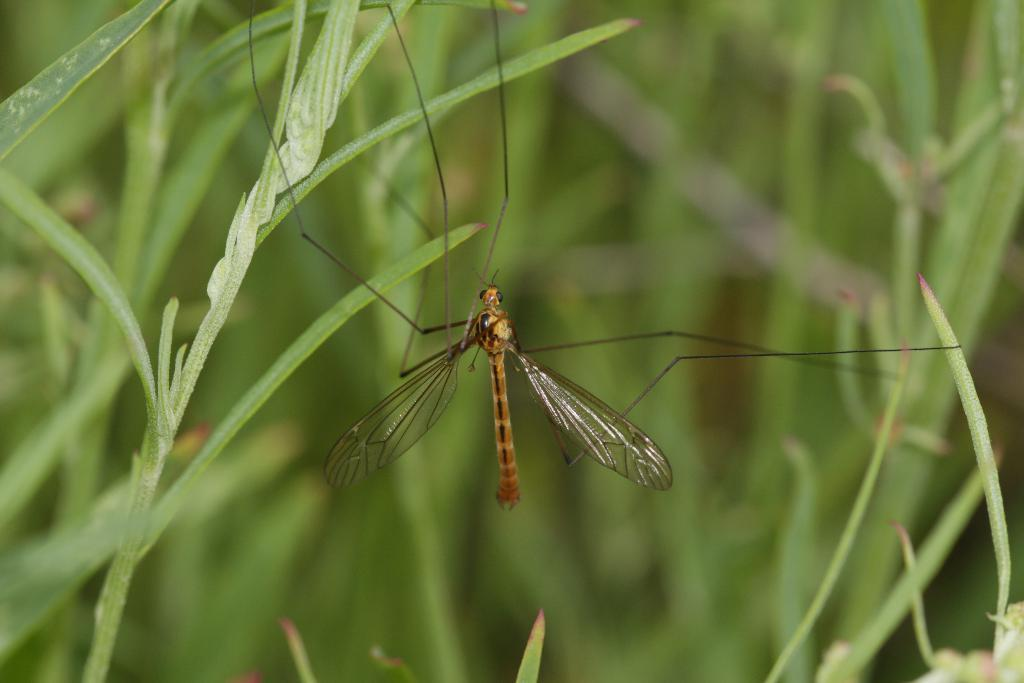What type of living organism can be seen in the picture? There is an insect in the picture. What can be seen in the background of the picture? There are plants visible in the background of the picture. What type of nail is being used to hold the drawer in the image? There is no drawer or nail present in the image; it only features an insect and plants in the background. 